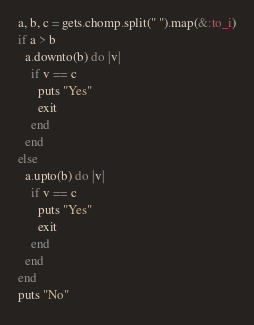Convert code to text. <code><loc_0><loc_0><loc_500><loc_500><_Ruby_>a, b, c = gets.chomp.split(" ").map(&:to_i)
if a > b
  a.downto(b) do |v|
    if v == c
      puts "Yes"
      exit
    end
  end
else
  a.upto(b) do |v|
    if v == c
      puts "Yes"
      exit
    end
  end
end
puts "No"
</code> 